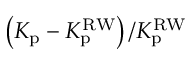<formula> <loc_0><loc_0><loc_500><loc_500>\left ( K _ { p } - K _ { p } ^ { R W } \right ) / K _ { p } ^ { R W }</formula> 